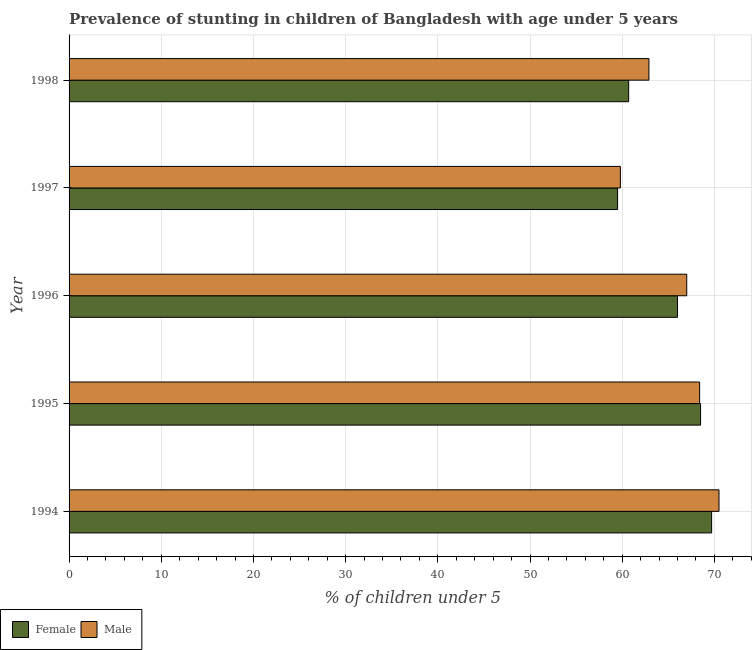How many different coloured bars are there?
Provide a short and direct response. 2. How many bars are there on the 1st tick from the top?
Provide a succinct answer. 2. In how many cases, is the number of bars for a given year not equal to the number of legend labels?
Make the answer very short. 0. What is the percentage of stunted male children in 1997?
Offer a terse response. 59.8. Across all years, what is the maximum percentage of stunted female children?
Offer a terse response. 69.7. Across all years, what is the minimum percentage of stunted male children?
Offer a very short reply. 59.8. What is the total percentage of stunted female children in the graph?
Give a very brief answer. 324.4. What is the difference between the percentage of stunted female children in 1998 and the percentage of stunted male children in 1996?
Ensure brevity in your answer.  -6.3. What is the average percentage of stunted female children per year?
Make the answer very short. 64.88. What is the ratio of the percentage of stunted male children in 1996 to that in 1997?
Make the answer very short. 1.12. What is the difference between the highest and the second highest percentage of stunted male children?
Offer a very short reply. 2.1. In how many years, is the percentage of stunted male children greater than the average percentage of stunted male children taken over all years?
Keep it short and to the point. 3. Is the sum of the percentage of stunted female children in 1996 and 1997 greater than the maximum percentage of stunted male children across all years?
Make the answer very short. Yes. What does the 2nd bar from the top in 1995 represents?
Offer a very short reply. Female. What does the 1st bar from the bottom in 1994 represents?
Provide a succinct answer. Female. Are all the bars in the graph horizontal?
Make the answer very short. Yes. How many years are there in the graph?
Give a very brief answer. 5. Does the graph contain any zero values?
Provide a short and direct response. No. Does the graph contain grids?
Your answer should be very brief. Yes. Where does the legend appear in the graph?
Your answer should be compact. Bottom left. How many legend labels are there?
Provide a succinct answer. 2. How are the legend labels stacked?
Your answer should be very brief. Horizontal. What is the title of the graph?
Keep it short and to the point. Prevalence of stunting in children of Bangladesh with age under 5 years. What is the label or title of the X-axis?
Your answer should be compact.  % of children under 5. What is the label or title of the Y-axis?
Make the answer very short. Year. What is the  % of children under 5 in Female in 1994?
Ensure brevity in your answer.  69.7. What is the  % of children under 5 in Male in 1994?
Offer a terse response. 70.5. What is the  % of children under 5 in Female in 1995?
Provide a succinct answer. 68.5. What is the  % of children under 5 in Male in 1995?
Ensure brevity in your answer.  68.4. What is the  % of children under 5 of Female in 1996?
Offer a terse response. 66. What is the  % of children under 5 in Male in 1996?
Make the answer very short. 67. What is the  % of children under 5 of Female in 1997?
Give a very brief answer. 59.5. What is the  % of children under 5 in Male in 1997?
Your answer should be compact. 59.8. What is the  % of children under 5 in Female in 1998?
Your answer should be very brief. 60.7. What is the  % of children under 5 in Male in 1998?
Give a very brief answer. 62.9. Across all years, what is the maximum  % of children under 5 in Female?
Provide a short and direct response. 69.7. Across all years, what is the maximum  % of children under 5 in Male?
Keep it short and to the point. 70.5. Across all years, what is the minimum  % of children under 5 of Female?
Make the answer very short. 59.5. Across all years, what is the minimum  % of children under 5 of Male?
Make the answer very short. 59.8. What is the total  % of children under 5 of Female in the graph?
Provide a short and direct response. 324.4. What is the total  % of children under 5 of Male in the graph?
Your answer should be compact. 328.6. What is the difference between the  % of children under 5 of Male in 1994 and that in 1995?
Offer a terse response. 2.1. What is the difference between the  % of children under 5 in Female in 1994 and that in 1997?
Make the answer very short. 10.2. What is the difference between the  % of children under 5 in Male in 1994 and that in 1997?
Offer a terse response. 10.7. What is the difference between the  % of children under 5 in Male in 1994 and that in 1998?
Offer a very short reply. 7.6. What is the difference between the  % of children under 5 of Female in 1995 and that in 1996?
Keep it short and to the point. 2.5. What is the difference between the  % of children under 5 of Male in 1995 and that in 1998?
Offer a terse response. 5.5. What is the difference between the  % of children under 5 in Female in 1996 and that in 1997?
Your response must be concise. 6.5. What is the difference between the  % of children under 5 in Male in 1996 and that in 1997?
Provide a succinct answer. 7.2. What is the difference between the  % of children under 5 in Male in 1996 and that in 1998?
Your answer should be compact. 4.1. What is the difference between the  % of children under 5 of Female in 1997 and that in 1998?
Provide a succinct answer. -1.2. What is the difference between the  % of children under 5 in Male in 1997 and that in 1998?
Make the answer very short. -3.1. What is the difference between the  % of children under 5 of Female in 1994 and the  % of children under 5 of Male in 1995?
Give a very brief answer. 1.3. What is the difference between the  % of children under 5 in Female in 1994 and the  % of children under 5 in Male in 1996?
Provide a succinct answer. 2.7. What is the difference between the  % of children under 5 in Female in 1994 and the  % of children under 5 in Male in 1997?
Offer a very short reply. 9.9. What is the difference between the  % of children under 5 in Female in 1995 and the  % of children under 5 in Male in 1996?
Give a very brief answer. 1.5. What is the difference between the  % of children under 5 of Female in 1995 and the  % of children under 5 of Male in 1997?
Keep it short and to the point. 8.7. What is the difference between the  % of children under 5 in Female in 1996 and the  % of children under 5 in Male in 1997?
Offer a terse response. 6.2. What is the average  % of children under 5 of Female per year?
Keep it short and to the point. 64.88. What is the average  % of children under 5 in Male per year?
Your answer should be compact. 65.72. In the year 1994, what is the difference between the  % of children under 5 of Female and  % of children under 5 of Male?
Provide a succinct answer. -0.8. In the year 1996, what is the difference between the  % of children under 5 in Female and  % of children under 5 in Male?
Make the answer very short. -1. What is the ratio of the  % of children under 5 in Female in 1994 to that in 1995?
Ensure brevity in your answer.  1.02. What is the ratio of the  % of children under 5 in Male in 1994 to that in 1995?
Keep it short and to the point. 1.03. What is the ratio of the  % of children under 5 in Female in 1994 to that in 1996?
Make the answer very short. 1.06. What is the ratio of the  % of children under 5 of Male in 1994 to that in 1996?
Your answer should be compact. 1.05. What is the ratio of the  % of children under 5 in Female in 1994 to that in 1997?
Provide a succinct answer. 1.17. What is the ratio of the  % of children under 5 in Male in 1994 to that in 1997?
Ensure brevity in your answer.  1.18. What is the ratio of the  % of children under 5 of Female in 1994 to that in 1998?
Your answer should be compact. 1.15. What is the ratio of the  % of children under 5 in Male in 1994 to that in 1998?
Provide a succinct answer. 1.12. What is the ratio of the  % of children under 5 in Female in 1995 to that in 1996?
Provide a short and direct response. 1.04. What is the ratio of the  % of children under 5 of Male in 1995 to that in 1996?
Ensure brevity in your answer.  1.02. What is the ratio of the  % of children under 5 in Female in 1995 to that in 1997?
Your answer should be compact. 1.15. What is the ratio of the  % of children under 5 in Male in 1995 to that in 1997?
Ensure brevity in your answer.  1.14. What is the ratio of the  % of children under 5 in Female in 1995 to that in 1998?
Keep it short and to the point. 1.13. What is the ratio of the  % of children under 5 of Male in 1995 to that in 1998?
Your response must be concise. 1.09. What is the ratio of the  % of children under 5 in Female in 1996 to that in 1997?
Your response must be concise. 1.11. What is the ratio of the  % of children under 5 of Male in 1996 to that in 1997?
Keep it short and to the point. 1.12. What is the ratio of the  % of children under 5 of Female in 1996 to that in 1998?
Provide a short and direct response. 1.09. What is the ratio of the  % of children under 5 of Male in 1996 to that in 1998?
Your response must be concise. 1.07. What is the ratio of the  % of children under 5 in Female in 1997 to that in 1998?
Give a very brief answer. 0.98. What is the ratio of the  % of children under 5 of Male in 1997 to that in 1998?
Give a very brief answer. 0.95. What is the difference between the highest and the second highest  % of children under 5 of Male?
Keep it short and to the point. 2.1. What is the difference between the highest and the lowest  % of children under 5 in Female?
Your answer should be compact. 10.2. What is the difference between the highest and the lowest  % of children under 5 in Male?
Give a very brief answer. 10.7. 